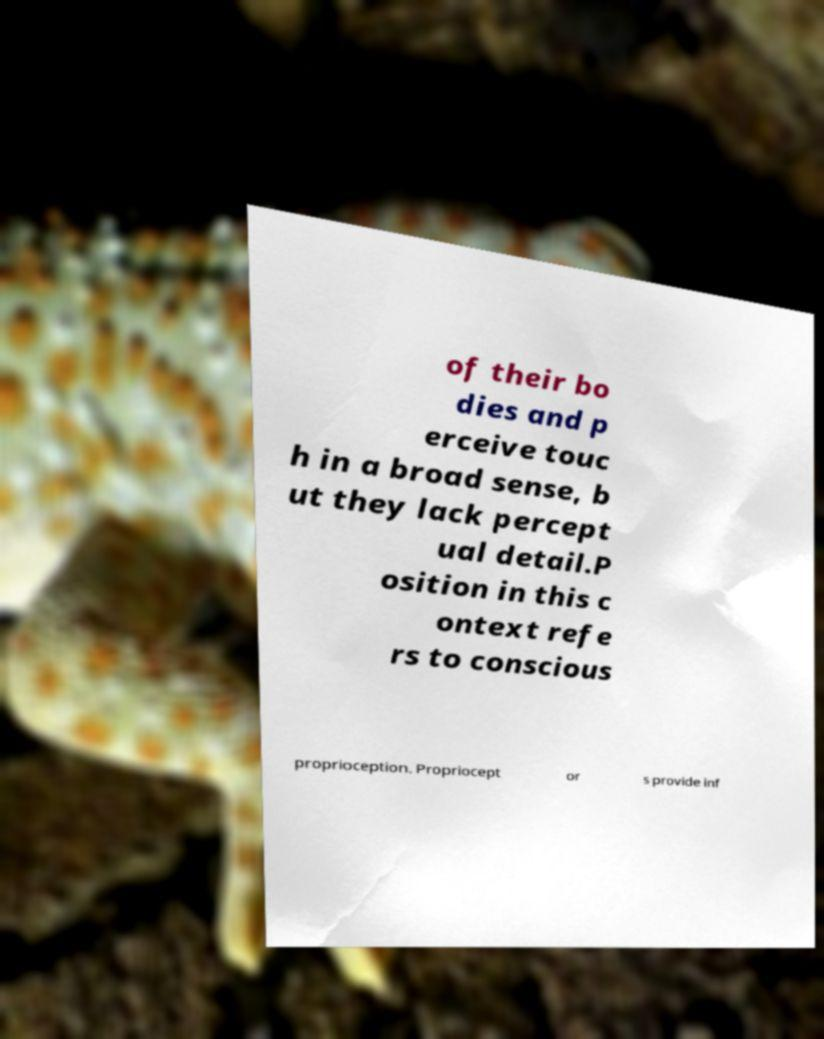Can you accurately transcribe the text from the provided image for me? of their bo dies and p erceive touc h in a broad sense, b ut they lack percept ual detail.P osition in this c ontext refe rs to conscious proprioception. Propriocept or s provide inf 